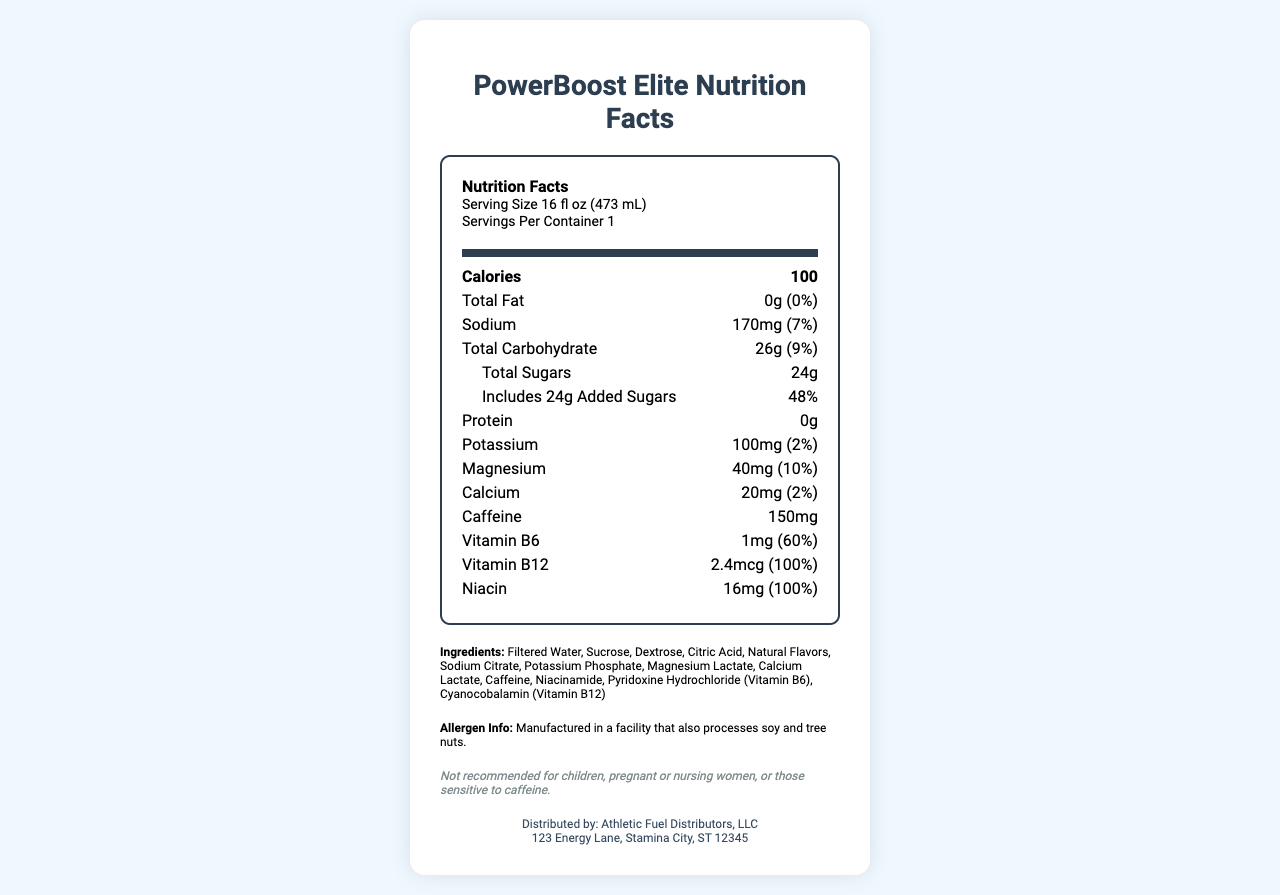what is the serving size of PowerBoost Elite? The serving size is mentioned near the top under the "Serving Size" section.
Answer: 16 fl oz (473 mL) how many calories are in one serving? The number of calories is listed under the "Calories" section.
Answer: 100 how much sodium is there in PowerBoost Elite? The sodium content is specified as "170mg" in the sodium section.
Answer: 170mg what is the daily value percentage of Vitamin B12? The daily value percentage of Vitamin B12 is mentioned as "100%" in the vitamin B12 section.
Answer: 100% how much caffeine does PowerBoost Elite contain? The caffeine content is listed as "150mg" in the caffeine section.
Answer: 150mg what are the total carbohydrates present in one serving? The total carbohydrate content is listed as "26g" in the total carbohydrate section.
Answer: 26g how much added sugars are there in this energy drink? The amount of added sugars is mentioned as "24g" under the total sugars section.
Answer: 24g how much magnesium is there in PowerBoost Elite? The magnesium content is specified as "40mg" in the magnesium section.
Answer: 40mg What allergen information is provided for PowerBoost Elite? The allergen information states that the product is manufactured in a facility that processes soy and tree nuts.
Answer: Manufactured in a facility that also processes soy and tree nuts. how much calcium does PowerBoost Elite contain? The calcium content is specified as "20mg" in the calcium section.
Answer: 20mg which vitamin has the highest daily value percentage? The daily value percentage of Vitamin B12 is "100%", which is higher than the other vitamins listed.
Answer: Vitamin B12 which of these ingredients is not present in PowerBoost Elite? A. Filtered Water B. Sucrose C. Aspartame D. Dextrose Aspartame is not listed among the ingredients for PowerBoost Elite.
Answer: C. Aspartame what is the daily value percentage of Niacin in PowerBoost Elite? The daily value percentage of Niacin is listed as "100%" in the Niacin section.
Answer: 100% true or false: PowerBoost Elite is recommended for children. The disclaimer at the bottom states that it is not recommended for children.
Answer: False summarize the key nutritional information of PowerBoost Elite. The summary provides a comprehensive overview of the nutritional values per serving size of PowerBoost Elite, listing major components and their daily value percentages.
Answer: PowerBoost Elite is a sports energy drink consisting of 100 calories per 16 fl oz serving. It contains 0g total fat, 170mg sodium (7% daily value), 26g total carbohydrates (9% daily value), 24g total sugars (24g added sugars, 48% daily value), 0g protein, 100mg potassium (2% daily value), 40mg magnesium (10% daily value), 20mg calcium (2% daily value), 150mg caffeine, 1mg vitamin B6 (60% daily value), 2.4mcg vitamin B12 (100% daily value), and 16mg niacin (100% daily value). what is the source of the calcium in PowerBoost Elite? The document does not specify the source of the calcium beyond its inclusion in the ingredient list as "Calcium Lactate."
Answer: Not enough information 